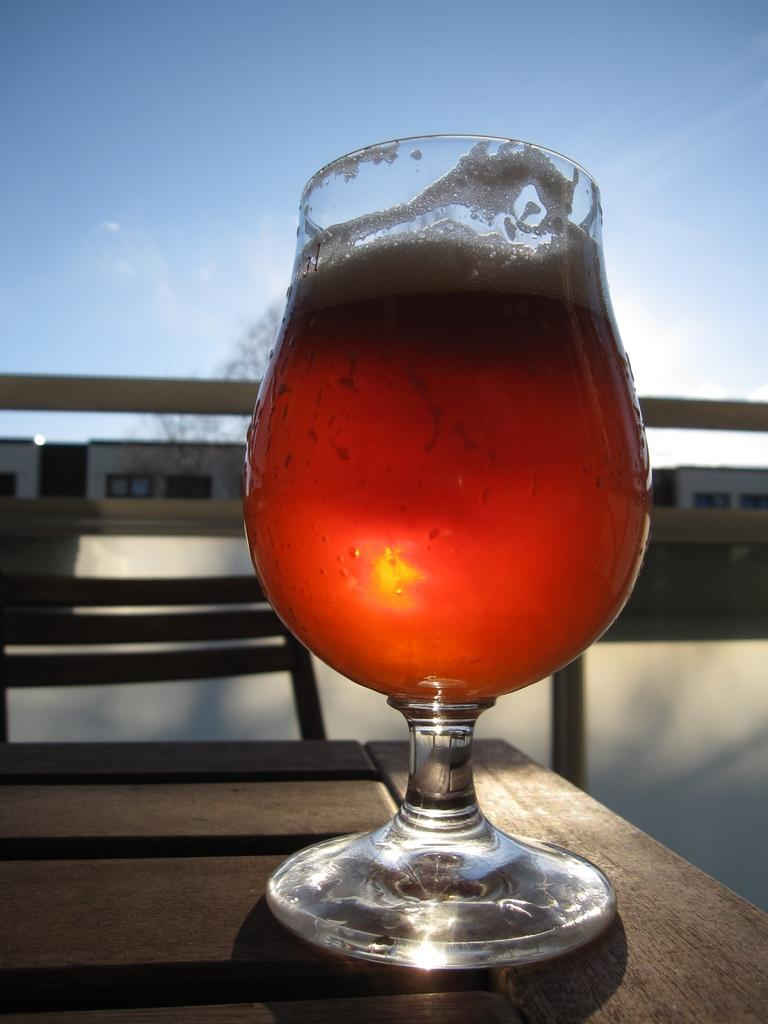What is in the glass that is visible in the image? The liquid in the glass is orange in color. Where is the glass located in the image? The glass is on a table. What can be seen in the background of the image? There are buildings visible in the background of the image. How would you describe the color of the sky in the image? The sky is white and blue in color. What type of guide is present in the image to help navigate the substance on the board? There is no guide or substance on a board present in the image. 